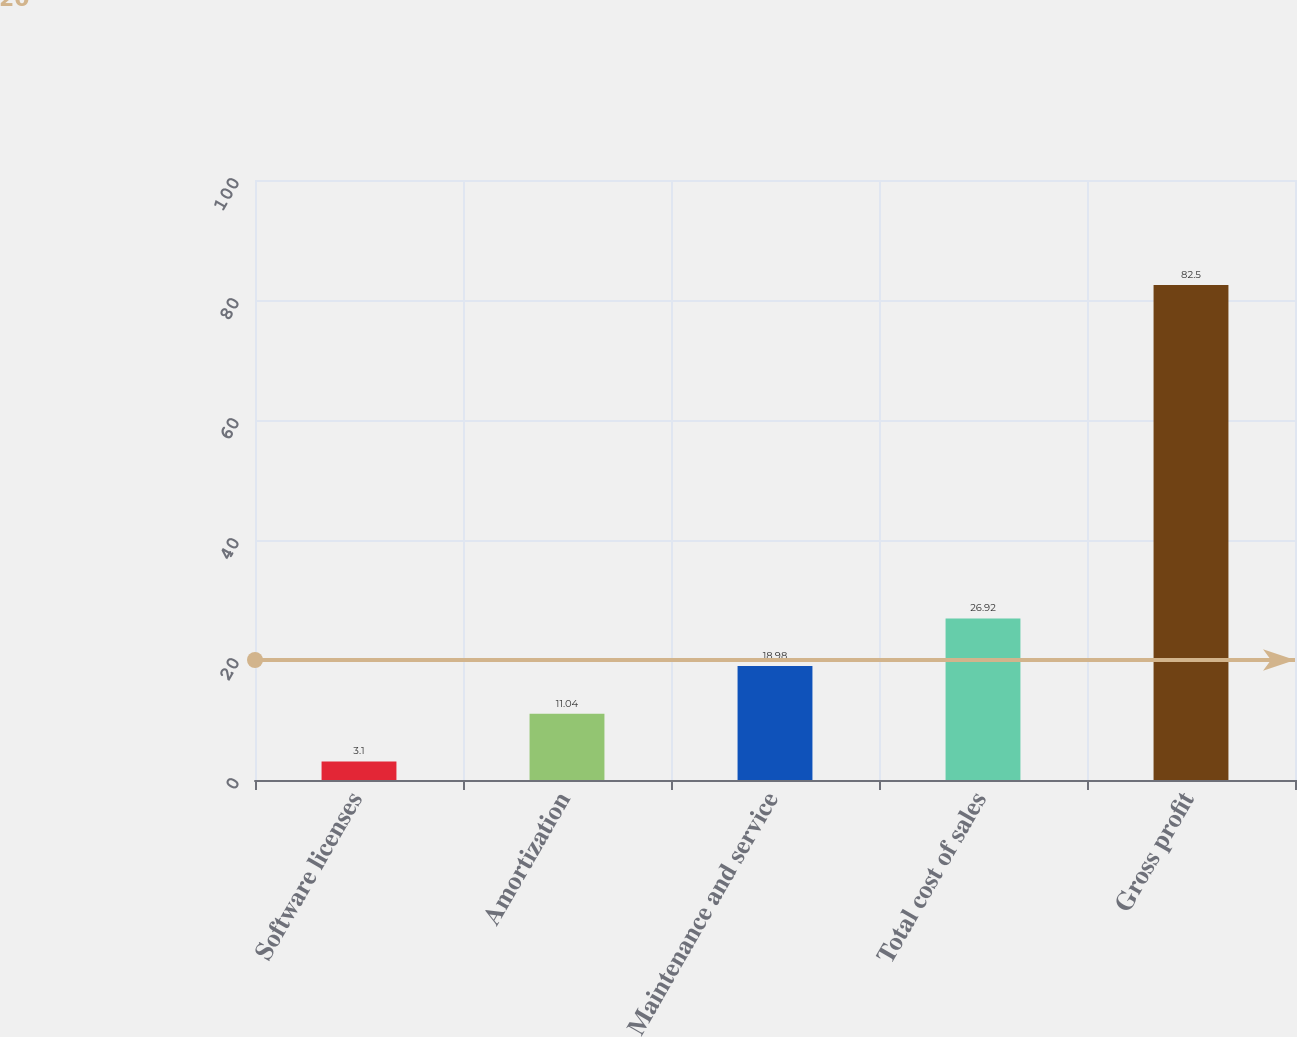Convert chart. <chart><loc_0><loc_0><loc_500><loc_500><bar_chart><fcel>Software licenses<fcel>Amortization<fcel>Maintenance and service<fcel>Total cost of sales<fcel>Gross profit<nl><fcel>3.1<fcel>11.04<fcel>18.98<fcel>26.92<fcel>82.5<nl></chart> 